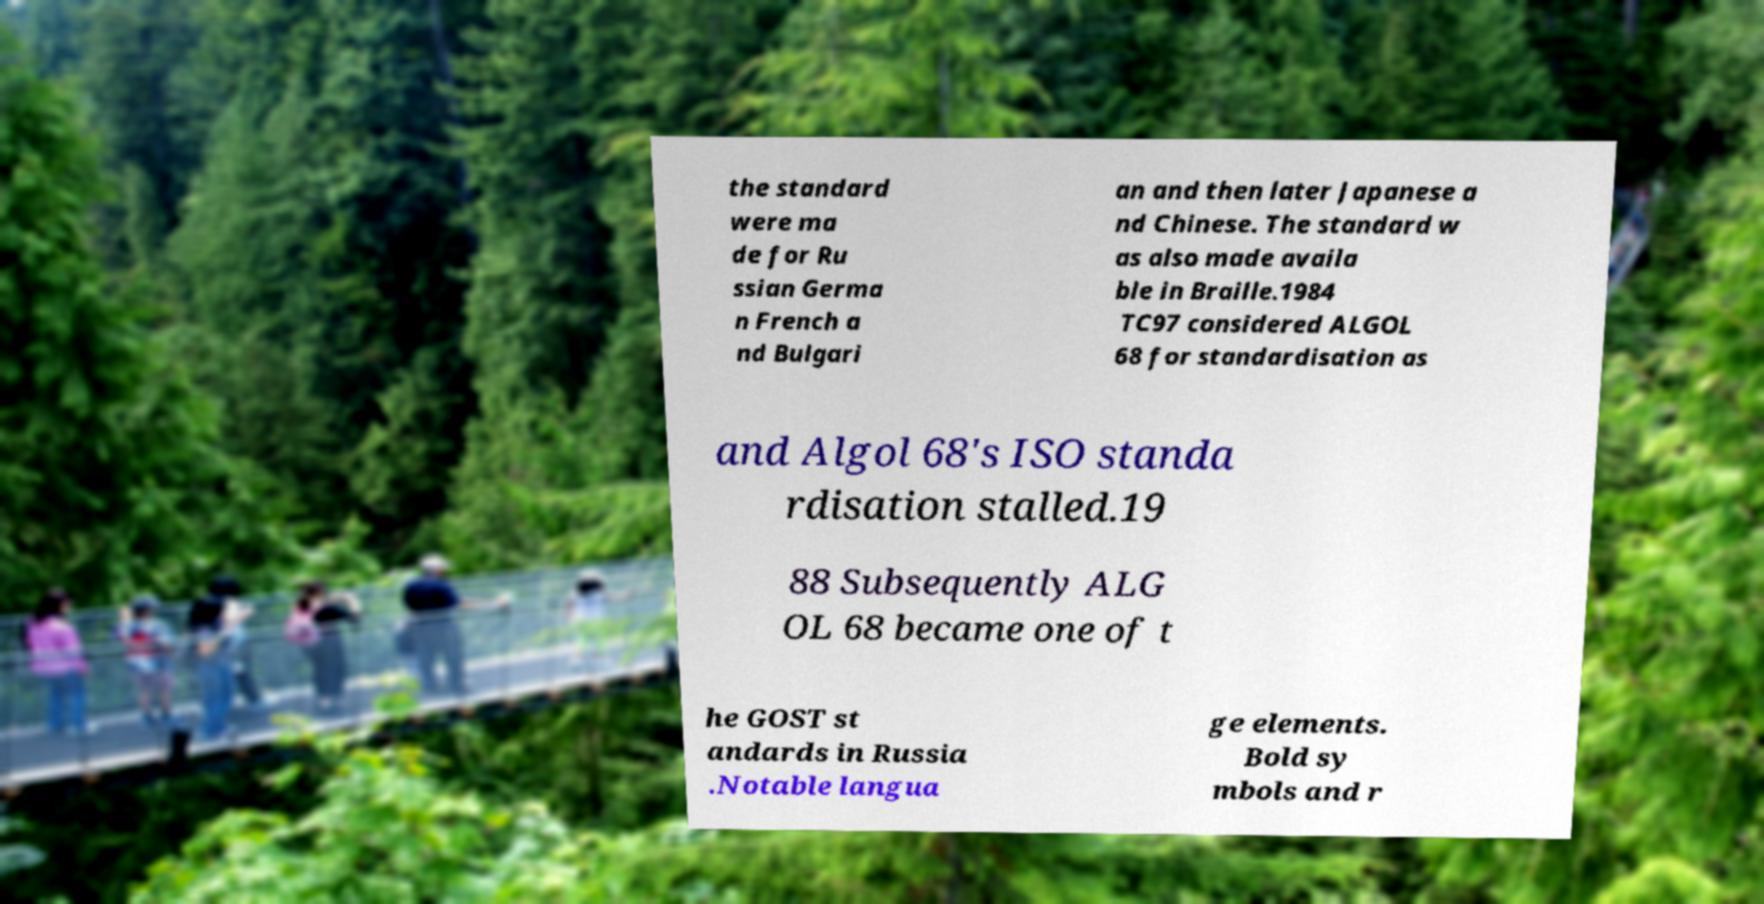Please read and relay the text visible in this image. What does it say? the standard were ma de for Ru ssian Germa n French a nd Bulgari an and then later Japanese a nd Chinese. The standard w as also made availa ble in Braille.1984 TC97 considered ALGOL 68 for standardisation as and Algol 68's ISO standa rdisation stalled.19 88 Subsequently ALG OL 68 became one of t he GOST st andards in Russia .Notable langua ge elements. Bold sy mbols and r 